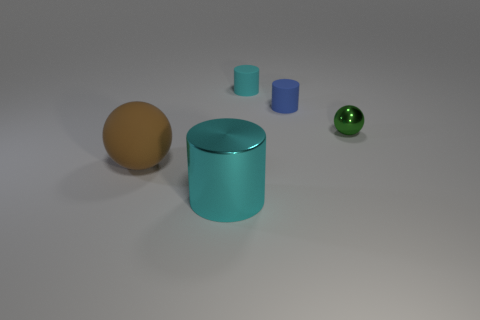Subtract all cyan rubber cylinders. How many cylinders are left? 2 Subtract all blue cylinders. How many cylinders are left? 2 Subtract 2 cylinders. How many cylinders are left? 1 Add 5 large brown balls. How many objects exist? 10 Subtract all cylinders. How many objects are left? 2 Subtract 0 brown blocks. How many objects are left? 5 Subtract all gray balls. Subtract all green blocks. How many balls are left? 2 Subtract all blue cubes. How many green balls are left? 1 Subtract all big cylinders. Subtract all tiny blue rubber cylinders. How many objects are left? 3 Add 5 small blue matte things. How many small blue matte things are left? 6 